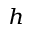<formula> <loc_0><loc_0><loc_500><loc_500>_ { h }</formula> 